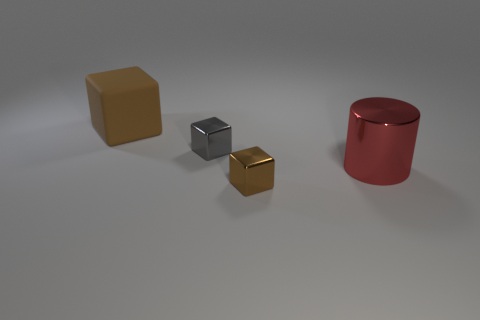Can you explain the lighting in this scene? The lighting in this scene suggests a diffuse overhead source, as indicated by the soft shadows under the objects with no sharp or harsh lines, and the consistent light across the scene, suggesting an environment with controlled, ambient lighting. 